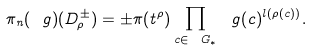<formula> <loc_0><loc_0><loc_500><loc_500>\pi _ { n } ( \ g ) ( D _ { \rho } ^ { \pm } ) = \pm \pi ( t ^ { \rho } ) \prod _ { c \in \ G _ { * } } \ g ( c ) ^ { l ( \rho ( c ) ) } .</formula> 